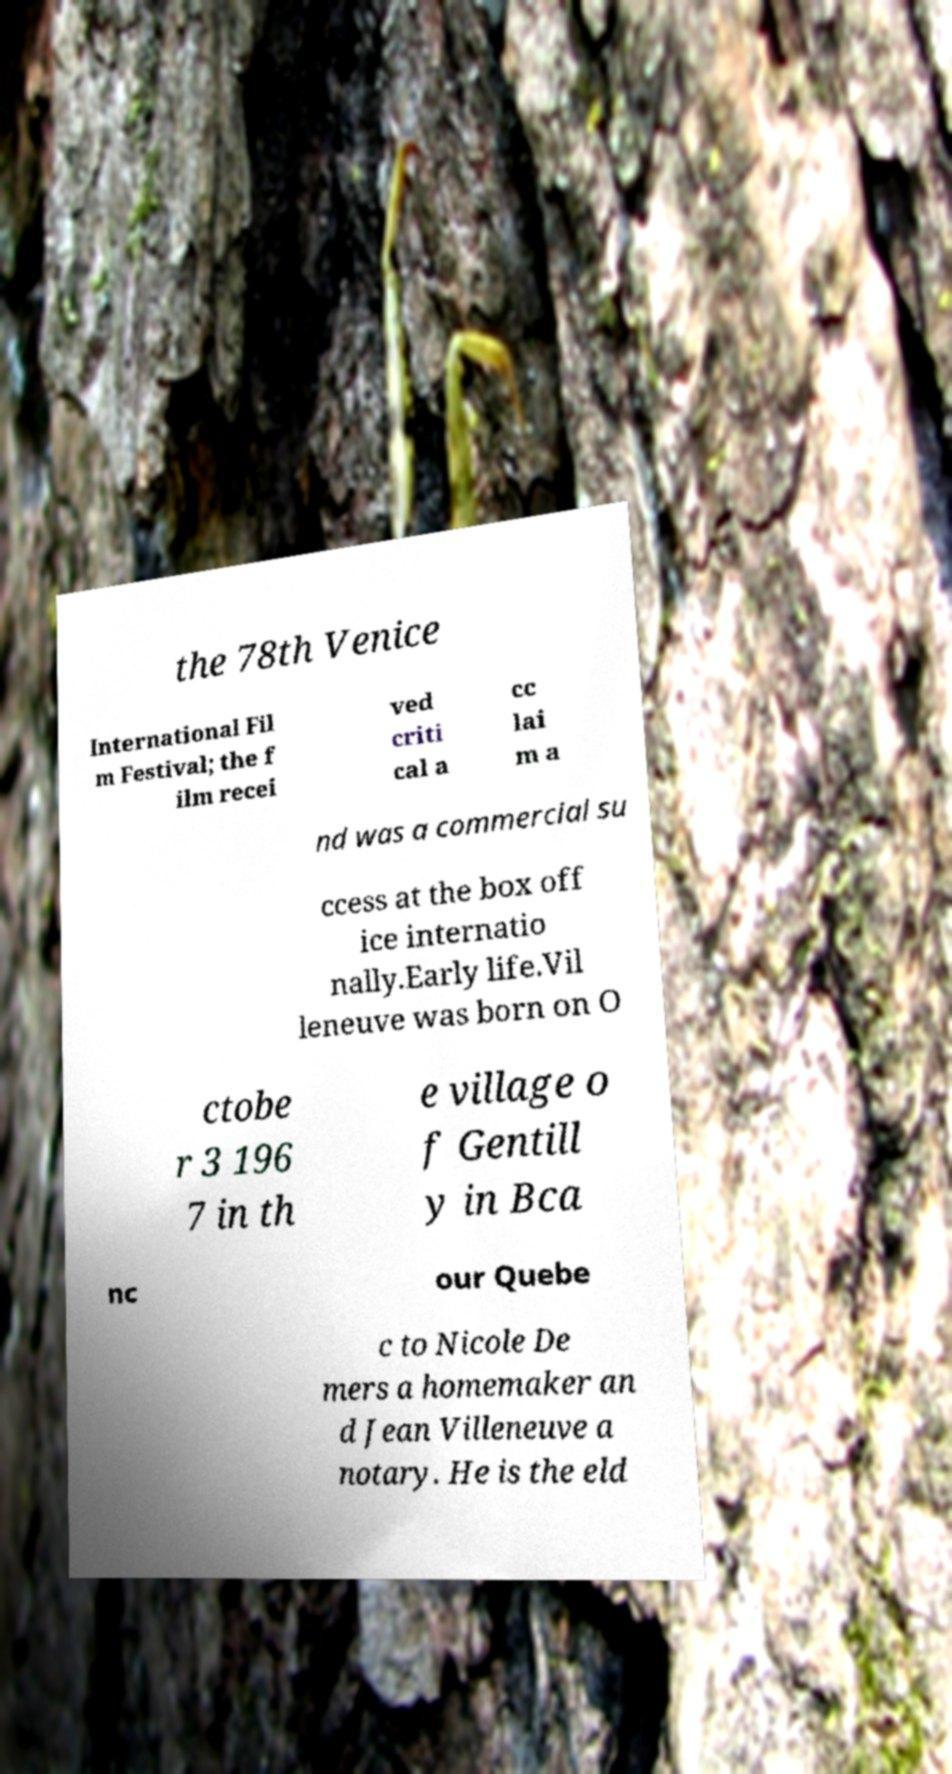Could you extract and type out the text from this image? the 78th Venice International Fil m Festival; the f ilm recei ved criti cal a cc lai m a nd was a commercial su ccess at the box off ice internatio nally.Early life.Vil leneuve was born on O ctobe r 3 196 7 in th e village o f Gentill y in Bca nc our Quebe c to Nicole De mers a homemaker an d Jean Villeneuve a notary. He is the eld 